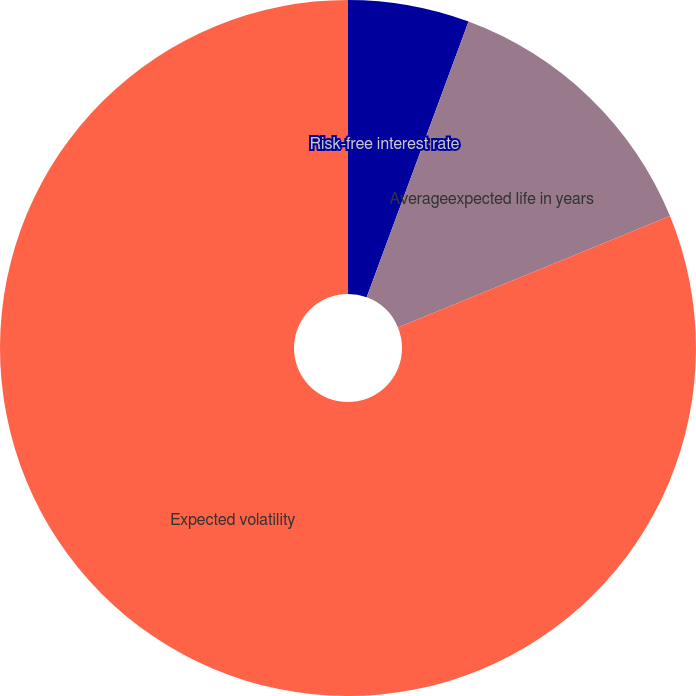<chart> <loc_0><loc_0><loc_500><loc_500><pie_chart><fcel>Risk-free interest rate<fcel>Averageexpected life in years<fcel>Expected volatility<nl><fcel>5.63%<fcel>13.18%<fcel>81.19%<nl></chart> 